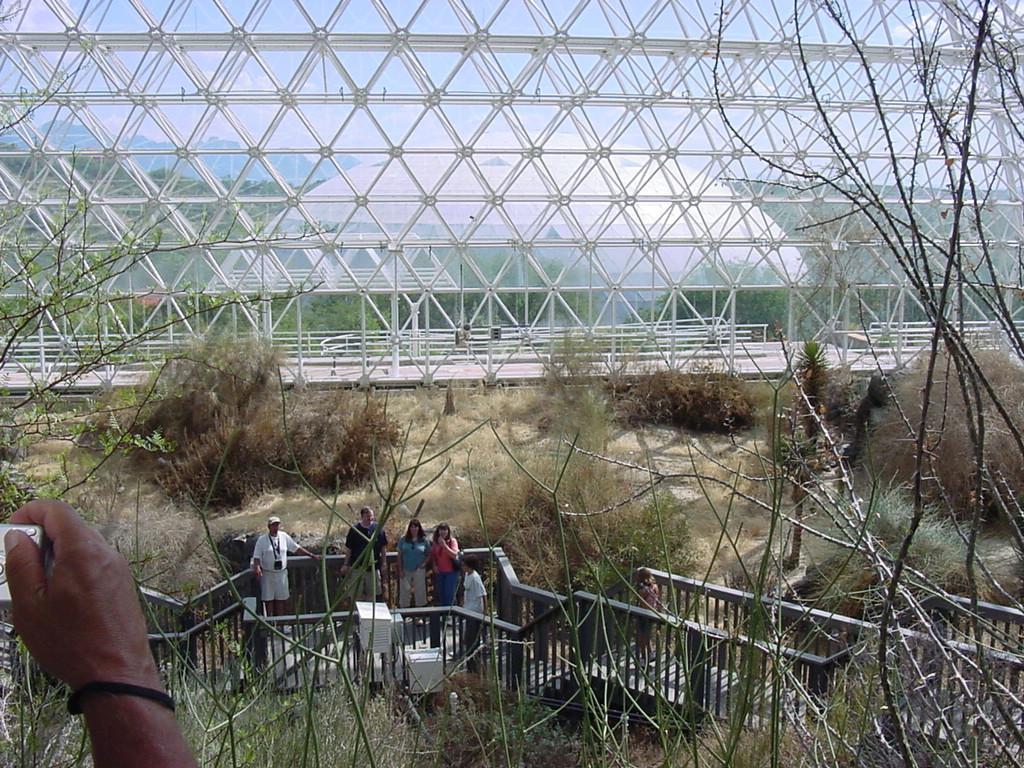Please provide a concise description of this image. In this image there is the sky towards the top of the image, there are trees, there is a road, there is a glass wall towards the top of the image, there are plants towards the bottom of the image, there are persons standing, there is a man wearing a cap, there is a person's hand towards the bottom of the image, there is an object in the person's hand. 